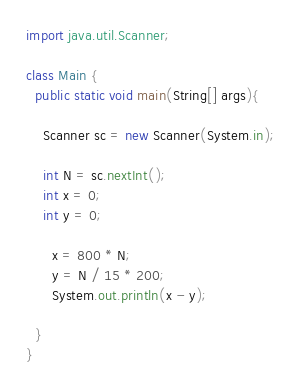<code> <loc_0><loc_0><loc_500><loc_500><_Java_>
import java.util.Scanner;

class Main {
  public static void main(String[] args){

    Scanner sc = new Scanner(System.in);

    int N = sc.nextInt();
    int x = 0;
    int y = 0;

      x = 800 * N;
      y = N / 15 * 200;
      System.out.println(x - y);

  }
}
</code> 